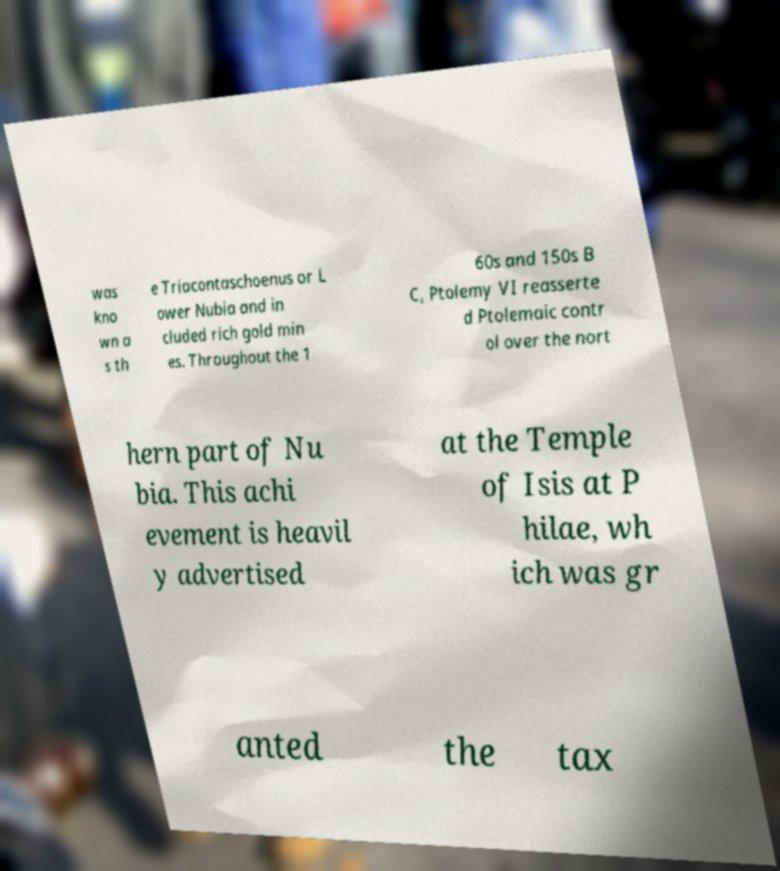For documentation purposes, I need the text within this image transcribed. Could you provide that? was kno wn a s th e Triacontaschoenus or L ower Nubia and in cluded rich gold min es. Throughout the 1 60s and 150s B C, Ptolemy VI reasserte d Ptolemaic contr ol over the nort hern part of Nu bia. This achi evement is heavil y advertised at the Temple of Isis at P hilae, wh ich was gr anted the tax 